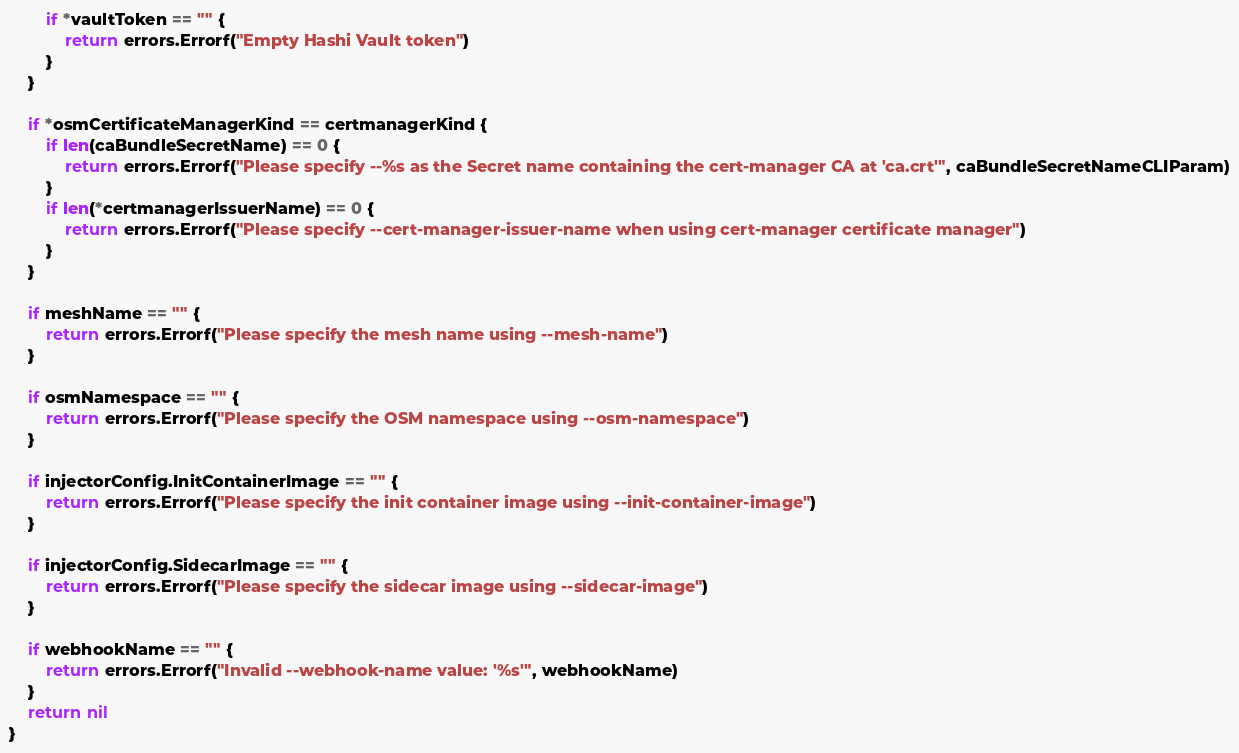Convert code to text. <code><loc_0><loc_0><loc_500><loc_500><_Go_>		if *vaultToken == "" {
			return errors.Errorf("Empty Hashi Vault token")
		}
	}

	if *osmCertificateManagerKind == certmanagerKind {
		if len(caBundleSecretName) == 0 {
			return errors.Errorf("Please specify --%s as the Secret name containing the cert-manager CA at 'ca.crt'", caBundleSecretNameCLIParam)
		}
		if len(*certmanagerIssuerName) == 0 {
			return errors.Errorf("Please specify --cert-manager-issuer-name when using cert-manager certificate manager")
		}
	}

	if meshName == "" {
		return errors.Errorf("Please specify the mesh name using --mesh-name")
	}

	if osmNamespace == "" {
		return errors.Errorf("Please specify the OSM namespace using --osm-namespace")
	}

	if injectorConfig.InitContainerImage == "" {
		return errors.Errorf("Please specify the init container image using --init-container-image")
	}

	if injectorConfig.SidecarImage == "" {
		return errors.Errorf("Please specify the sidecar image using --sidecar-image")
	}

	if webhookName == "" {
		return errors.Errorf("Invalid --webhook-name value: '%s'", webhookName)
	}
	return nil
}
</code> 